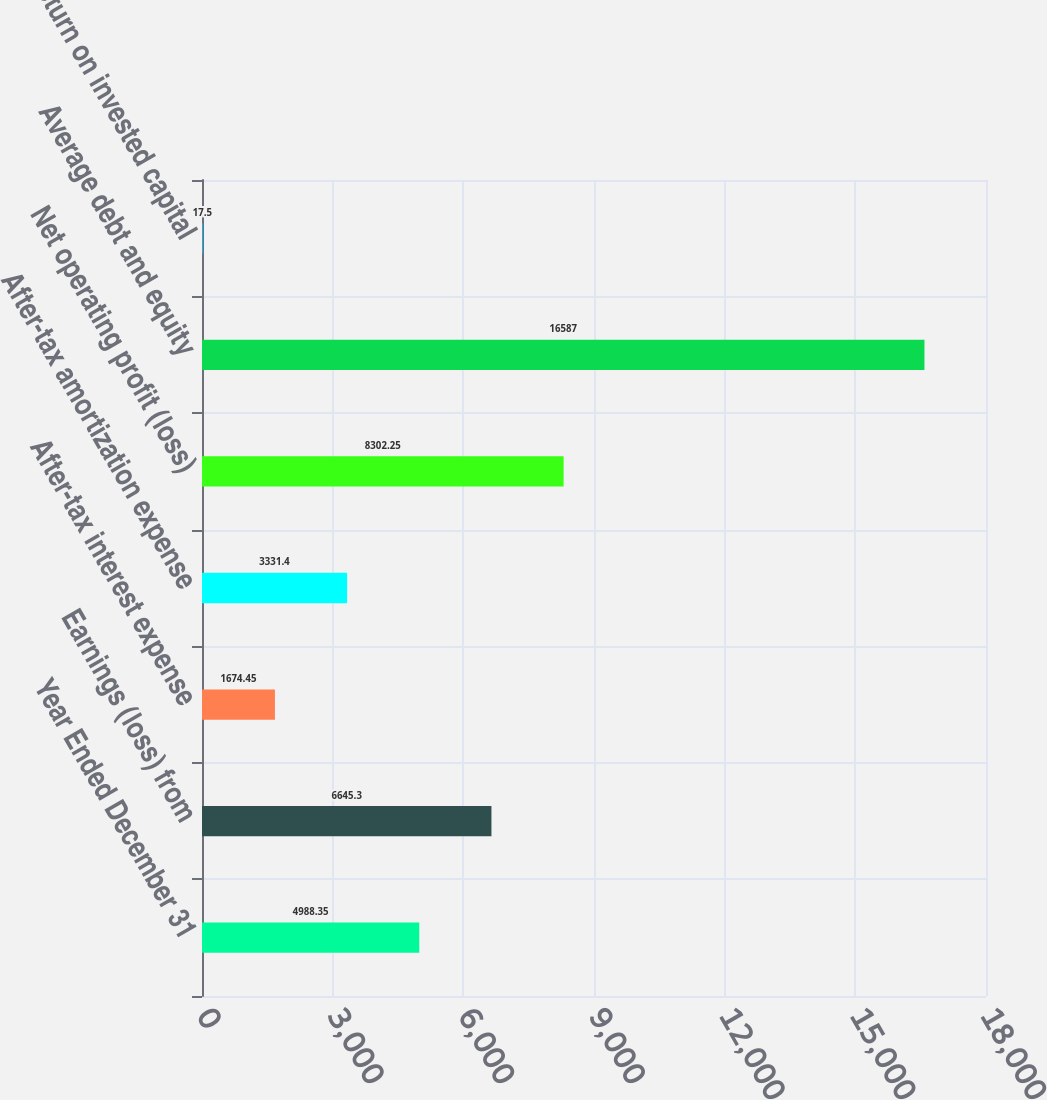<chart> <loc_0><loc_0><loc_500><loc_500><bar_chart><fcel>Year Ended December 31<fcel>Earnings (loss) from<fcel>After-tax interest expense<fcel>After-tax amortization expense<fcel>Net operating profit (loss)<fcel>Average debt and equity<fcel>Return on invested capital<nl><fcel>4988.35<fcel>6645.3<fcel>1674.45<fcel>3331.4<fcel>8302.25<fcel>16587<fcel>17.5<nl></chart> 